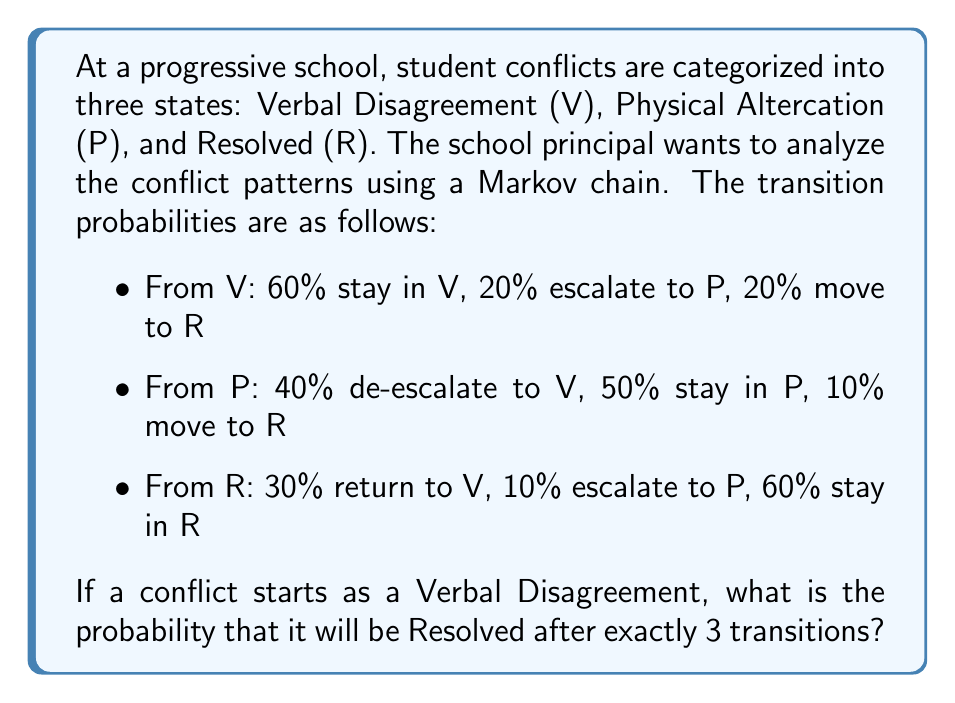Help me with this question. To solve this problem, we'll use the Markov chain transition matrix and calculate the probability of moving from state V to state R in exactly 3 steps.

Step 1: Set up the transition matrix P.
$$P = \begin{bmatrix}
0.6 & 0.2 & 0.2 \\
0.4 & 0.5 & 0.1 \\
0.3 & 0.1 & 0.6
\end{bmatrix}$$

Where the rows and columns represent V, P, and R in that order.

Step 2: Calculate $P^3$ to get the 3-step transition probabilities.
$$P^3 = P \times P \times P$$

We can use matrix multiplication or software to compute this:

$$P^3 = \begin{bmatrix}
0.468 & 0.226 & 0.306 \\
0.454 & 0.284 & 0.262 \\
0.3942 & 0.1746 & 0.4312
\end{bmatrix}$$

Step 3: Identify the probability of moving from V to R in 3 steps.
This is the entry in the first row, third column of $P^3$, which is 0.306.

Therefore, the probability that a conflict starting as a Verbal Disagreement will be Resolved after exactly 3 transitions is 0.306 or 30.6%.
Answer: 0.306 